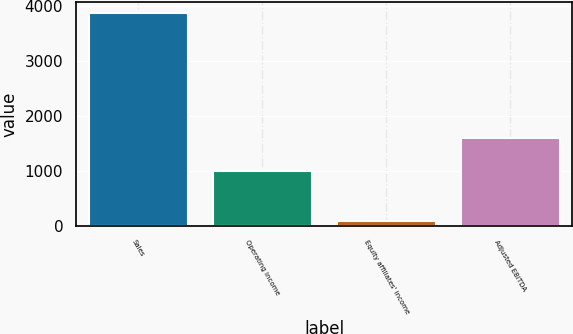Convert chart. <chart><loc_0><loc_0><loc_500><loc_500><bar_chart><fcel>Sales<fcel>Operating income<fcel>Equity affiliates' income<fcel>Adjusted EBITDA<nl><fcel>3873.5<fcel>997.7<fcel>84.8<fcel>1587.7<nl></chart> 